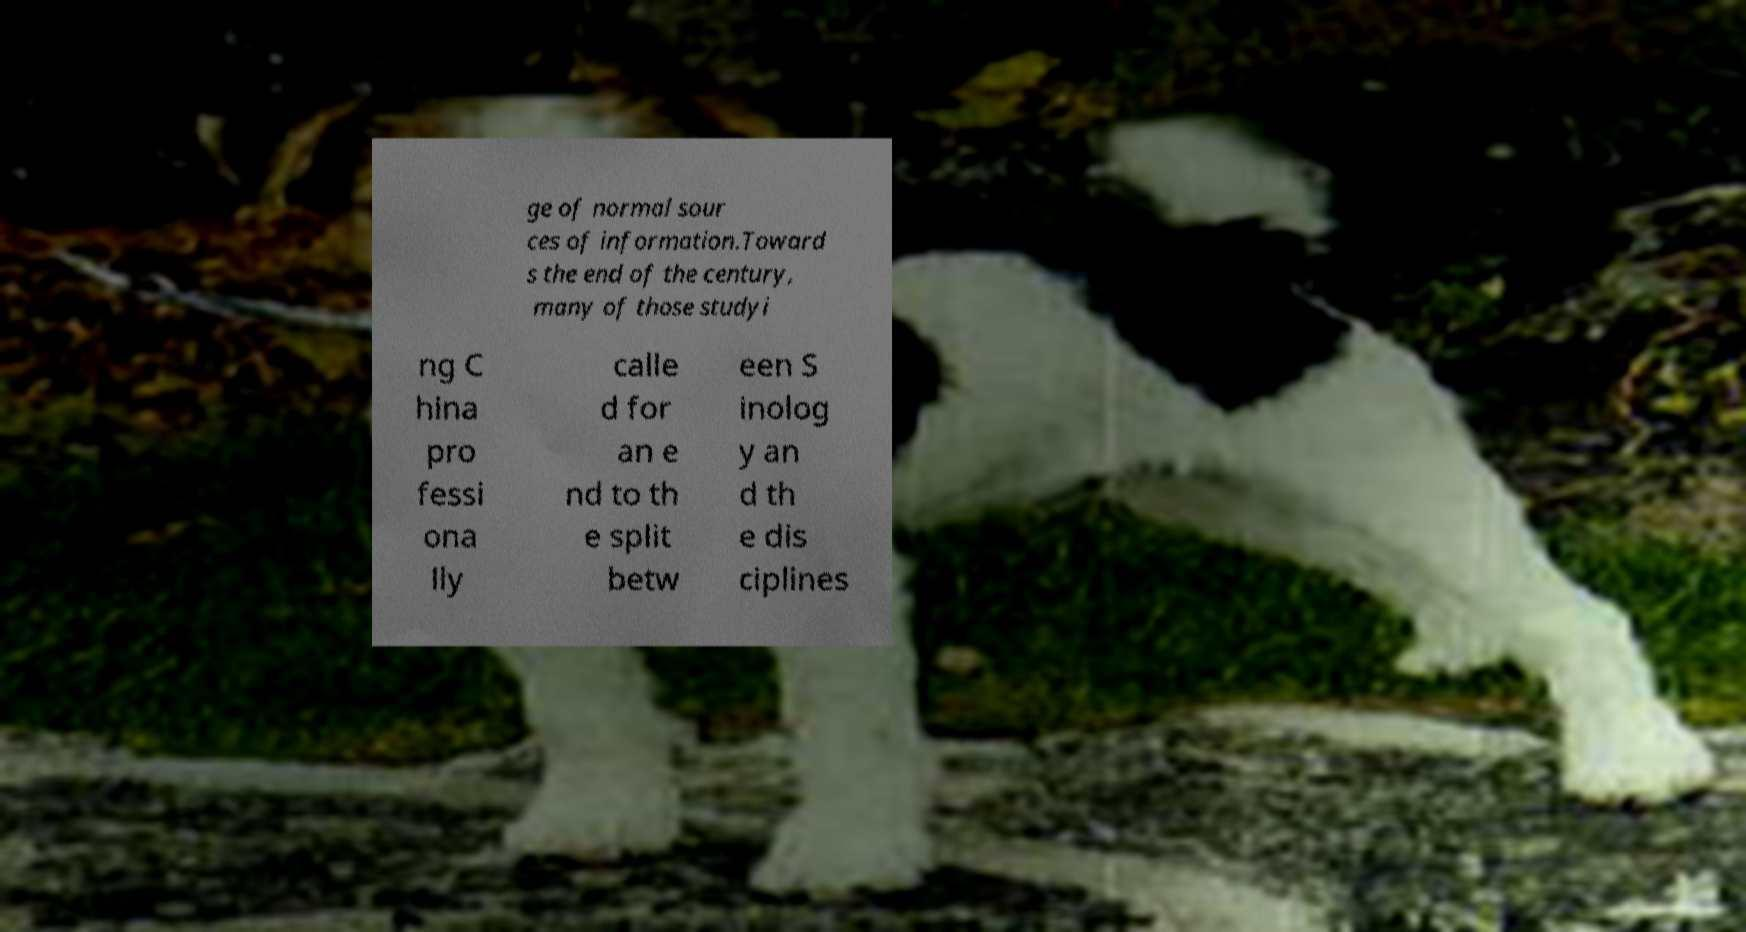I need the written content from this picture converted into text. Can you do that? ge of normal sour ces of information.Toward s the end of the century, many of those studyi ng C hina pro fessi ona lly calle d for an e nd to th e split betw een S inolog y an d th e dis ciplines 